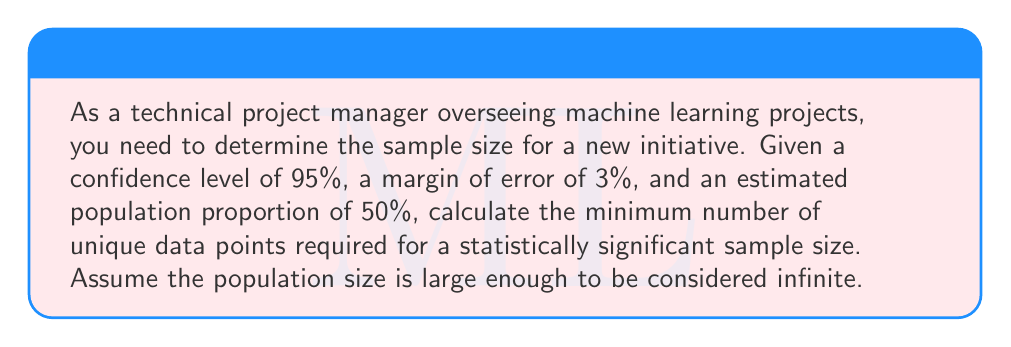Could you help me with this problem? To calculate the required sample size, we'll use the formula for sample size determination when estimating a population proportion:

$$n = \frac{z^2 * p(1-p)}{e^2}$$

Where:
$n$ = required sample size
$z$ = z-score (based on confidence level)
$p$ = estimated population proportion
$e$ = margin of error

Step 1: Determine the z-score for 95% confidence level
For 95% confidence, z = 1.96

Step 2: Use the given values in the formula
$p = 0.5$ (50% expressed as a decimal)
$e = 0.03$ (3% expressed as a decimal)

$$n = \frac{1.96^2 * 0.5(1-0.5)}{0.03^2}$$

Step 3: Calculate the result
$$n = \frac{3.8416 * 0.25}{0.0009}$$
$$n = \frac{0.9604}{0.0009}$$
$$n = 1067.11$$

Step 4: Round up to the nearest whole number
Since we can't have a fractional number of data points, we round up to 1068.
Answer: 1068 data points 